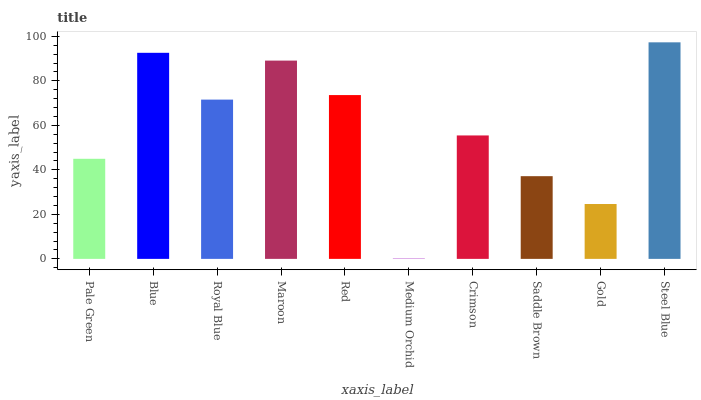Is Medium Orchid the minimum?
Answer yes or no. Yes. Is Steel Blue the maximum?
Answer yes or no. Yes. Is Blue the minimum?
Answer yes or no. No. Is Blue the maximum?
Answer yes or no. No. Is Blue greater than Pale Green?
Answer yes or no. Yes. Is Pale Green less than Blue?
Answer yes or no. Yes. Is Pale Green greater than Blue?
Answer yes or no. No. Is Blue less than Pale Green?
Answer yes or no. No. Is Royal Blue the high median?
Answer yes or no. Yes. Is Crimson the low median?
Answer yes or no. Yes. Is Steel Blue the high median?
Answer yes or no. No. Is Red the low median?
Answer yes or no. No. 